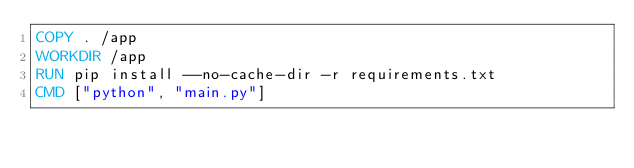Convert code to text. <code><loc_0><loc_0><loc_500><loc_500><_Dockerfile_>COPY . /app
WORKDIR /app
RUN pip install --no-cache-dir -r requirements.txt
CMD ["python", "main.py"]
</code> 